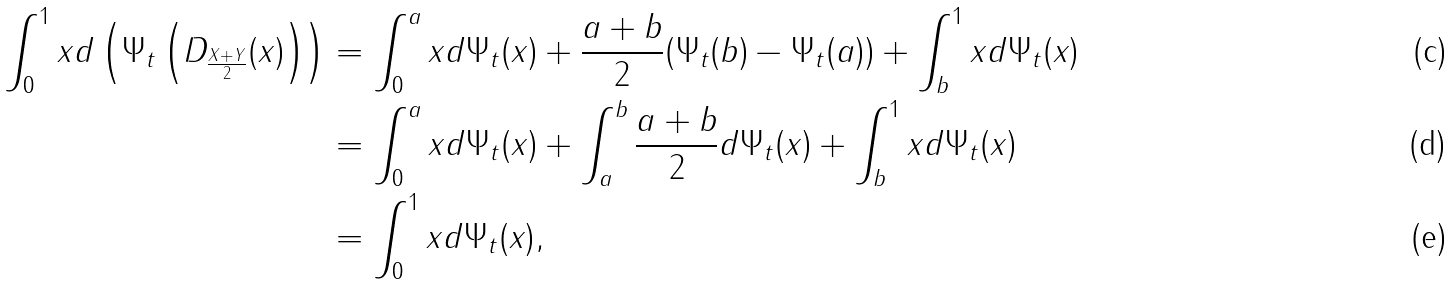Convert formula to latex. <formula><loc_0><loc_0><loc_500><loc_500>\int _ { 0 } ^ { 1 } x d \left ( \Psi _ { t } \left ( D _ { \frac { X + Y } { 2 } } ( x ) \right ) \right ) & = \int _ { 0 } ^ { a } x d \Psi _ { t } ( x ) + \frac { a + b } { 2 } ( \Psi _ { t } ( b ) - \Psi _ { t } ( a ) ) + \int _ { b } ^ { 1 } x d \Psi _ { t } ( x ) \\ & = \int _ { 0 } ^ { a } x d \Psi _ { t } ( x ) + \int _ { a } ^ { b } \frac { a + b } { 2 } d \Psi _ { t } ( x ) + \int _ { b } ^ { 1 } x d \Psi _ { t } ( x ) \\ & = \int _ { 0 } ^ { 1 } x d \Psi _ { t } ( x ) ,</formula> 